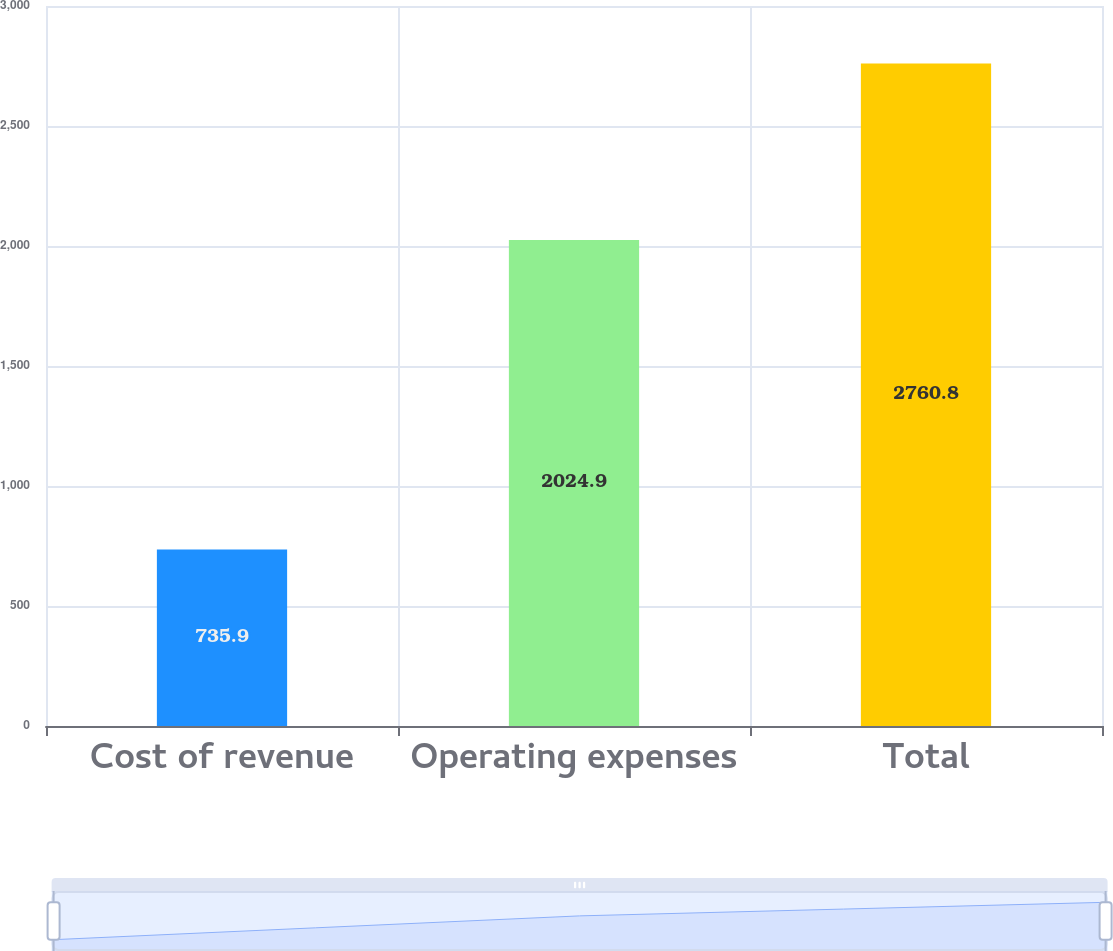<chart> <loc_0><loc_0><loc_500><loc_500><bar_chart><fcel>Cost of revenue<fcel>Operating expenses<fcel>Total<nl><fcel>735.9<fcel>2024.9<fcel>2760.8<nl></chart> 